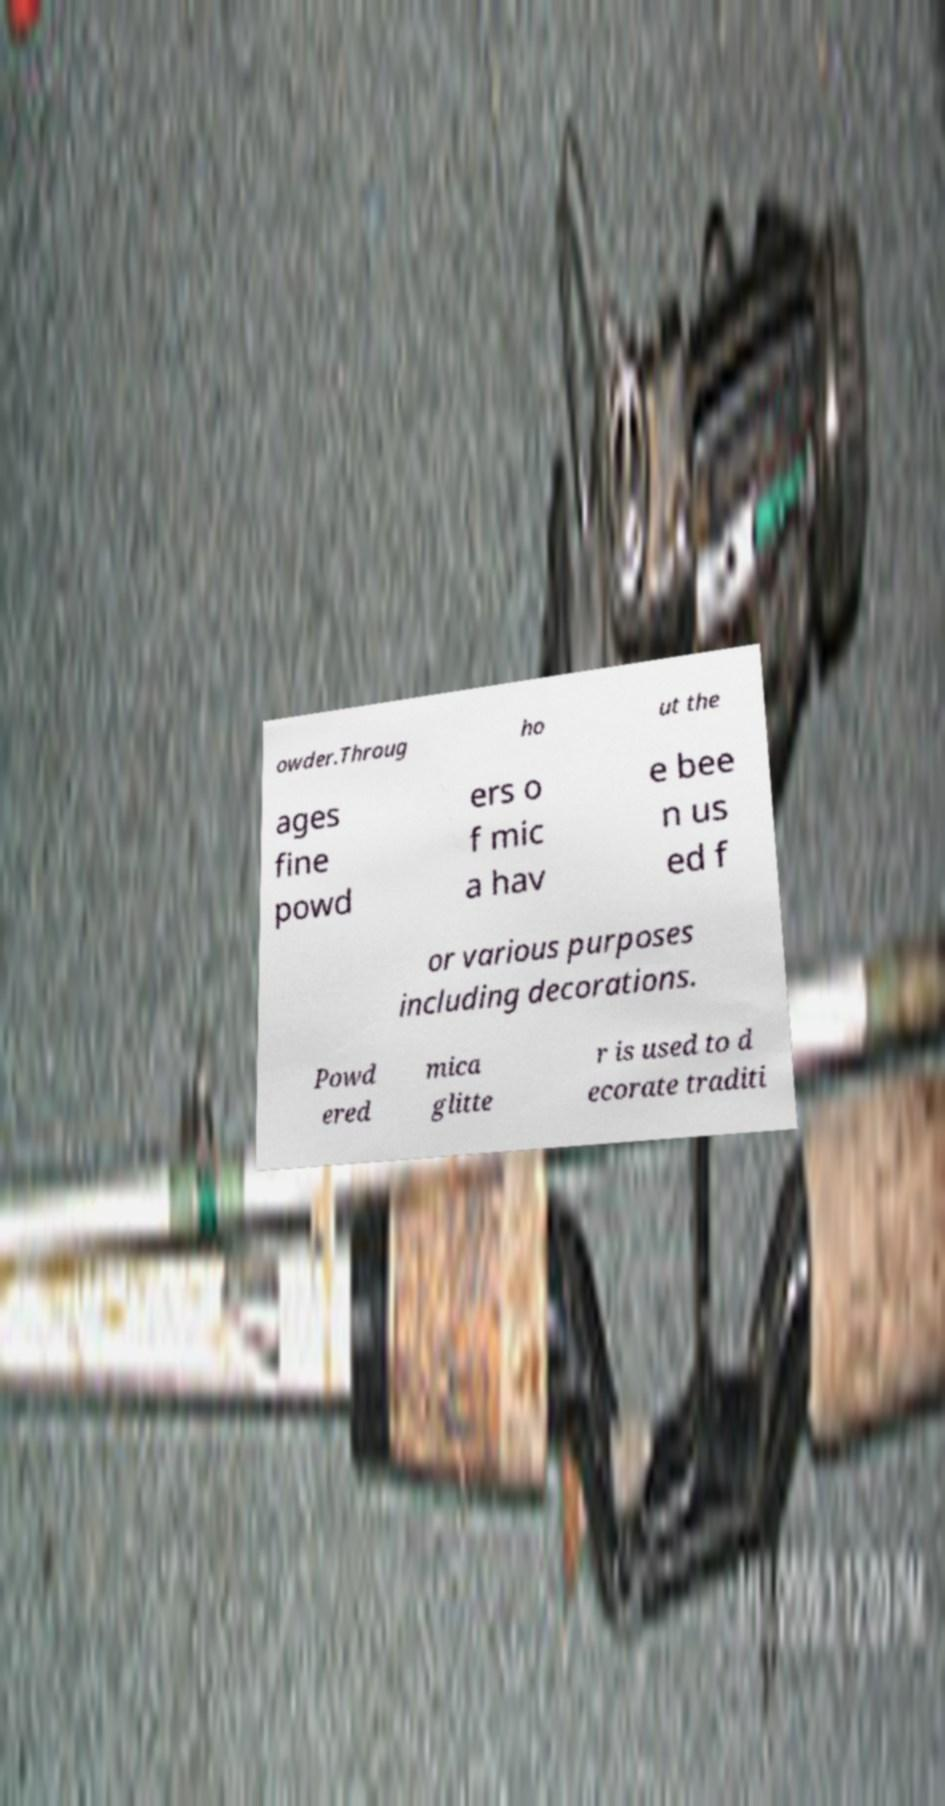Can you read and provide the text displayed in the image?This photo seems to have some interesting text. Can you extract and type it out for me? owder.Throug ho ut the ages fine powd ers o f mic a hav e bee n us ed f or various purposes including decorations. Powd ered mica glitte r is used to d ecorate traditi 